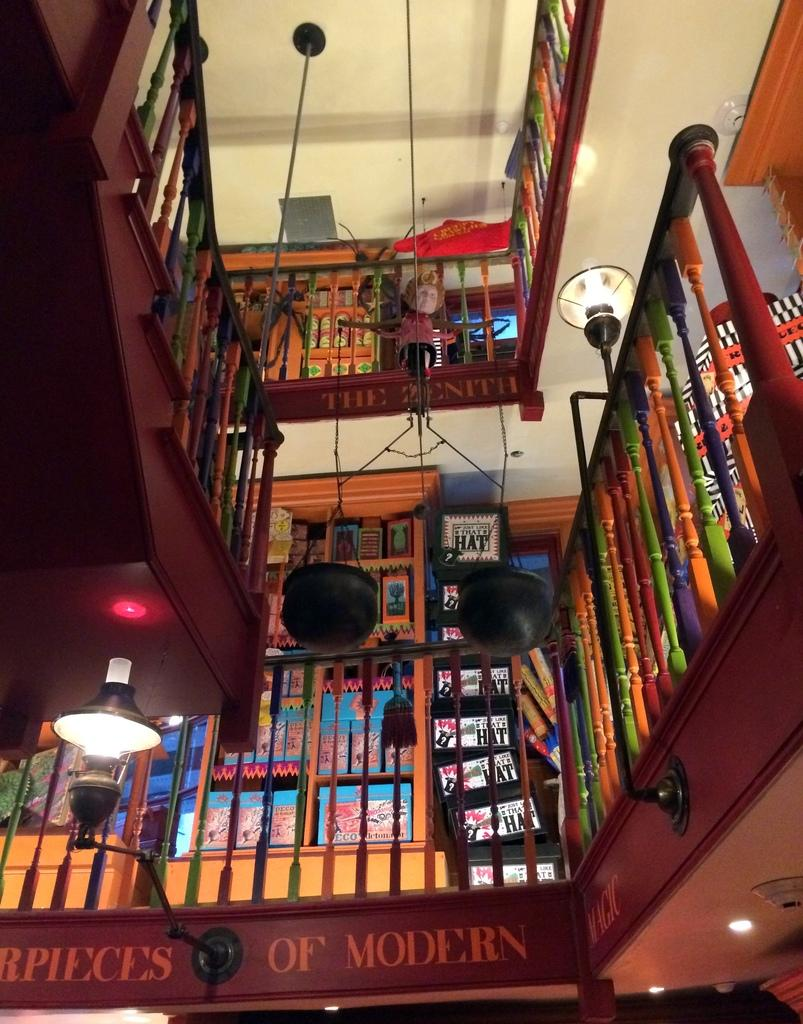<image>
Relay a brief, clear account of the picture shown. a sign that has the word hat on it in a library 